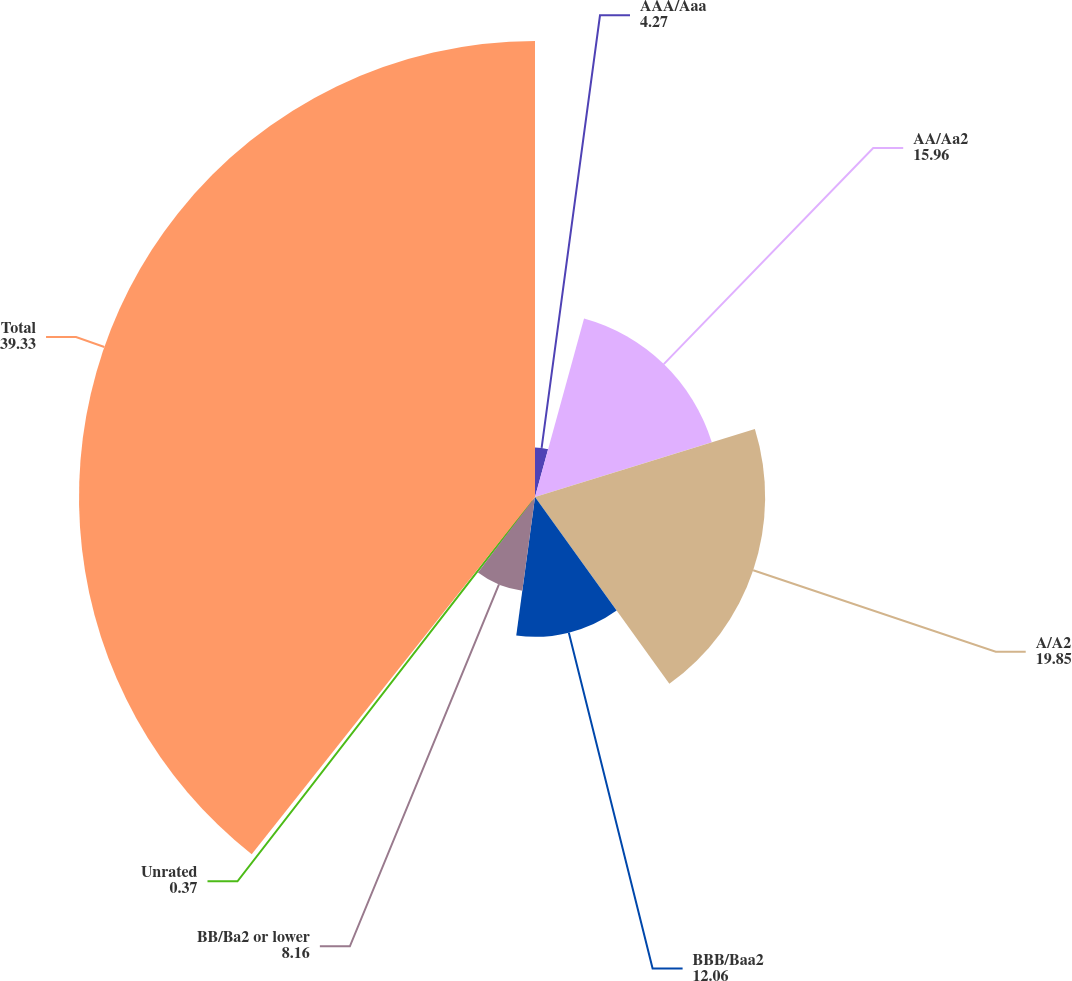Convert chart. <chart><loc_0><loc_0><loc_500><loc_500><pie_chart><fcel>AAA/Aaa<fcel>AA/Aa2<fcel>A/A2<fcel>BBB/Baa2<fcel>BB/Ba2 or lower<fcel>Unrated<fcel>Total<nl><fcel>4.27%<fcel>15.96%<fcel>19.85%<fcel>12.06%<fcel>8.16%<fcel>0.37%<fcel>39.33%<nl></chart> 